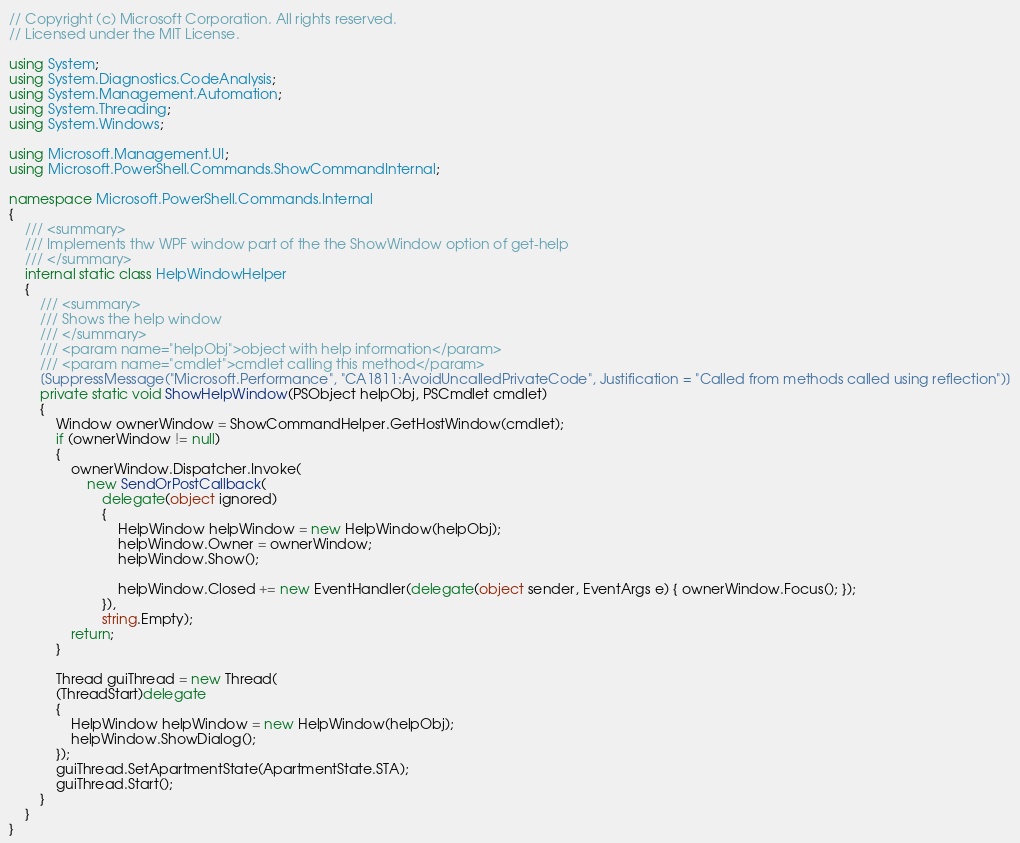Convert code to text. <code><loc_0><loc_0><loc_500><loc_500><_C#_>// Copyright (c) Microsoft Corporation. All rights reserved.
// Licensed under the MIT License.

using System;
using System.Diagnostics.CodeAnalysis;
using System.Management.Automation;
using System.Threading;
using System.Windows;

using Microsoft.Management.UI;
using Microsoft.PowerShell.Commands.ShowCommandInternal;

namespace Microsoft.PowerShell.Commands.Internal
{
    /// <summary>
    /// Implements thw WPF window part of the the ShowWindow option of get-help
    /// </summary>
    internal static class HelpWindowHelper
    {
        /// <summary>
        /// Shows the help window
        /// </summary>
        /// <param name="helpObj">object with help information</param>
        /// <param name="cmdlet">cmdlet calling this method</param>
        [SuppressMessage("Microsoft.Performance", "CA1811:AvoidUncalledPrivateCode", Justification = "Called from methods called using reflection")]
        private static void ShowHelpWindow(PSObject helpObj, PSCmdlet cmdlet)
        {
            Window ownerWindow = ShowCommandHelper.GetHostWindow(cmdlet);
            if (ownerWindow != null)
            {
                ownerWindow.Dispatcher.Invoke(
                    new SendOrPostCallback(
                        delegate(object ignored)
                        {
                            HelpWindow helpWindow = new HelpWindow(helpObj);
                            helpWindow.Owner = ownerWindow;
                            helpWindow.Show();

                            helpWindow.Closed += new EventHandler(delegate(object sender, EventArgs e) { ownerWindow.Focus(); });
                        }),
                        string.Empty);
                return;
            }

            Thread guiThread = new Thread(
            (ThreadStart)delegate
            {
                HelpWindow helpWindow = new HelpWindow(helpObj);
                helpWindow.ShowDialog();
            });
            guiThread.SetApartmentState(ApartmentState.STA);
            guiThread.Start();
        }
    }
}
</code> 